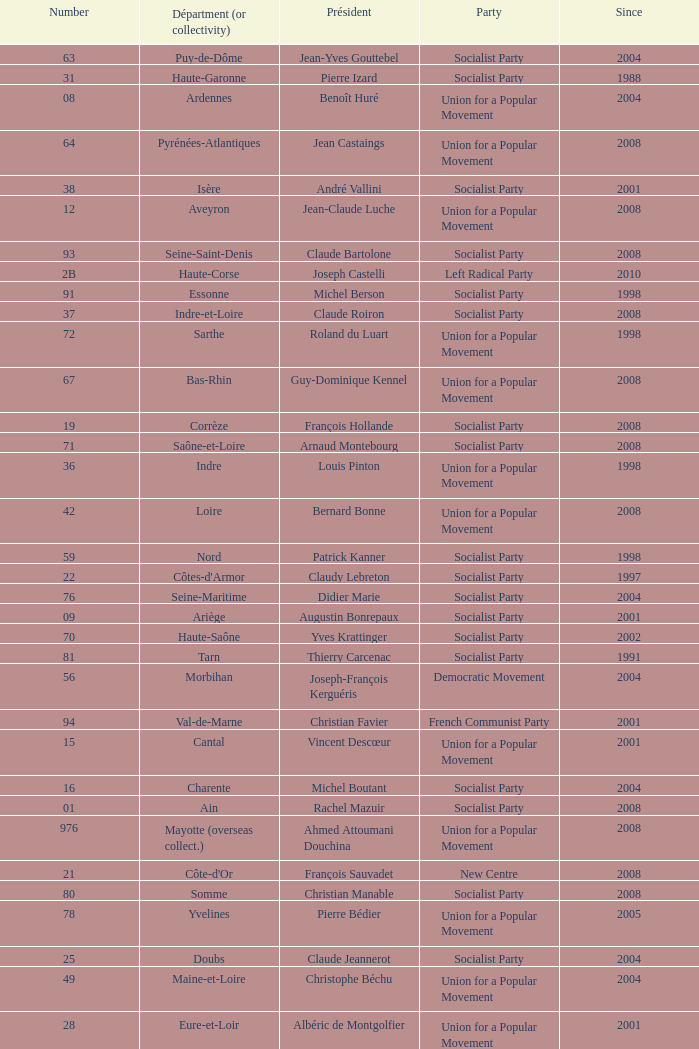Which department has Guy-Dominique Kennel as president since 2008? Bas-Rhin. 